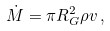Convert formula to latex. <formula><loc_0><loc_0><loc_500><loc_500>\dot { M } = \pi R _ { G } ^ { 2 } \rho v \, ,</formula> 